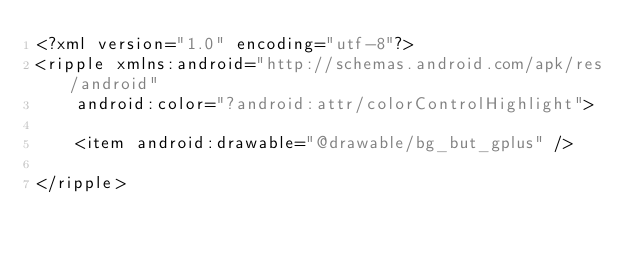Convert code to text. <code><loc_0><loc_0><loc_500><loc_500><_XML_><?xml version="1.0" encoding="utf-8"?>
<ripple xmlns:android="http://schemas.android.com/apk/res/android"
    android:color="?android:attr/colorControlHighlight">

    <item android:drawable="@drawable/bg_but_gplus" />

</ripple></code> 